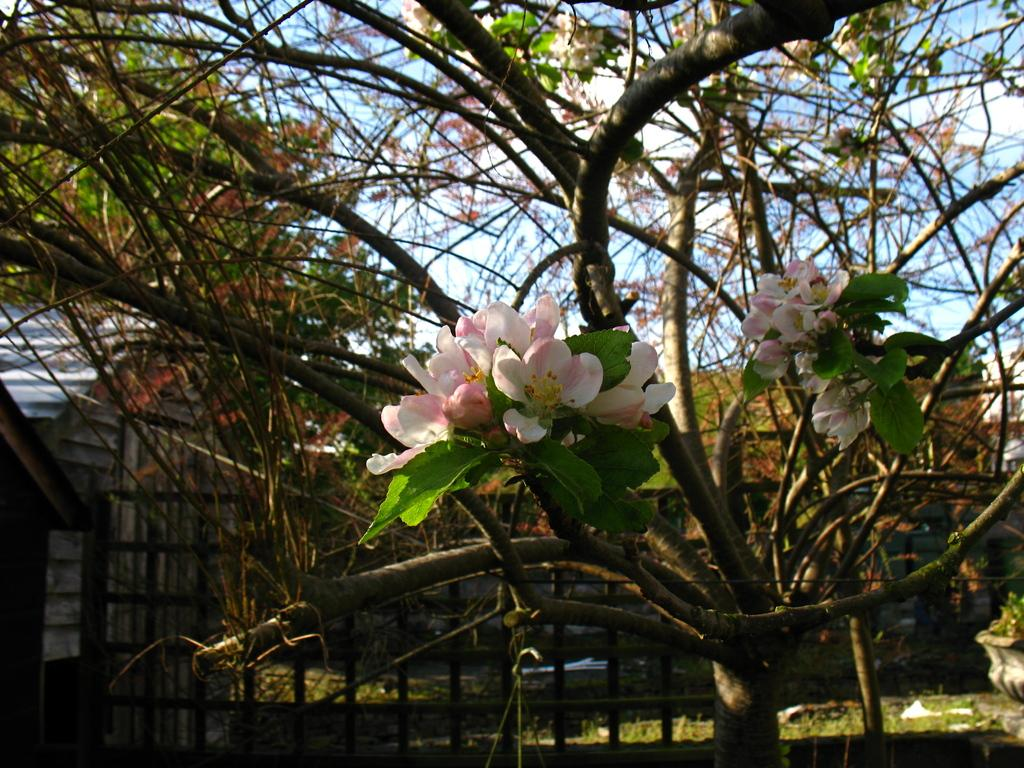What types of flowers are present in the image? There are white and pink color flowers in the image. What color are the leaves in the image? The leaves in the image are green. What can be seen in the background of the image? Trees and huts are visible in the background of the image. What is the color of the sky in the image? The sky is blue and white in color. How many balls are being used to weigh down the flowers in the image? There are no balls present in the image, and the flowers are not being weighed down. 